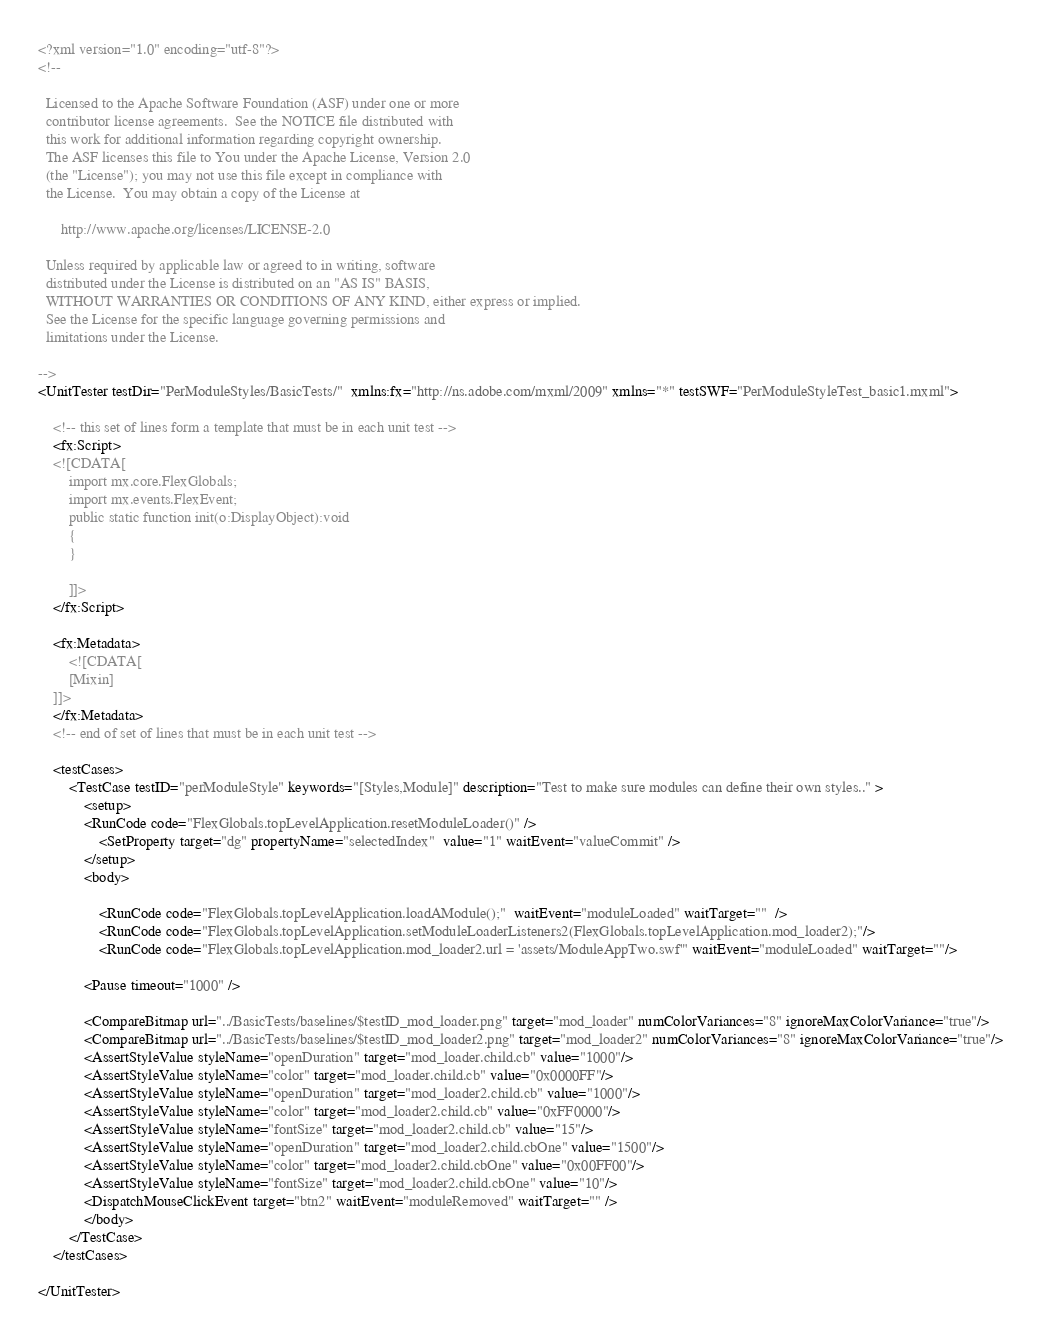Convert code to text. <code><loc_0><loc_0><loc_500><loc_500><_XML_><?xml version="1.0" encoding="utf-8"?>
<!--

  Licensed to the Apache Software Foundation (ASF) under one or more
  contributor license agreements.  See the NOTICE file distributed with
  this work for additional information regarding copyright ownership.
  The ASF licenses this file to You under the Apache License, Version 2.0
  (the "License"); you may not use this file except in compliance with
  the License.  You may obtain a copy of the License at

      http://www.apache.org/licenses/LICENSE-2.0

  Unless required by applicable law or agreed to in writing, software
  distributed under the License is distributed on an "AS IS" BASIS,
  WITHOUT WARRANTIES OR CONDITIONS OF ANY KIND, either express or implied.
  See the License for the specific language governing permissions and
  limitations under the License.

-->
<UnitTester testDir="PerModuleStyles/BasicTests/"  xmlns:fx="http://ns.adobe.com/mxml/2009" xmlns="*" testSWF="PerModuleStyleTest_basic1.mxml">

	<!-- this set of lines form a template that must be in each unit test -->
	<fx:Script>
	<![CDATA[
		import mx.core.FlexGlobals;
		import mx.events.FlexEvent;	
		public static function init(o:DisplayObject):void
		{
		}
		
		]]>
	</fx:Script>

	<fx:Metadata>
		<![CDATA[
		[Mixin]
	]]>
	</fx:Metadata>
	<!-- end of set of lines that must be in each unit test -->

	<testCases>
		<TestCase testID="perModuleStyle" keywords="[Styles,Module]" description="Test to make sure modules can define their own styles.." >
		    <setup>
		   	<RunCode code="FlexGlobals.topLevelApplication.resetModuleLoader()" />
		    	<SetProperty target="dg" propertyName="selectedIndex"  value="1" waitEvent="valueCommit" />
		    </setup>
		    <body>		
		    	
		    	<RunCode code="FlexGlobals.topLevelApplication.loadAModule();"  waitEvent="moduleLoaded" waitTarget=""  />
		    	<RunCode code="FlexGlobals.topLevelApplication.setModuleLoaderListeners2(FlexGlobals.topLevelApplication.mod_loader2);"/>
		    	<RunCode code="FlexGlobals.topLevelApplication.mod_loader2.url = 'assets/ModuleAppTwo.swf'" waitEvent="moduleLoaded" waitTarget=""/>
		    	
			<Pause timeout="1000" />
			
			<CompareBitmap url="../BasicTests/baselines/$testID_mod_loader.png" target="mod_loader" numColorVariances="8" ignoreMaxColorVariance="true"/>
			<CompareBitmap url="../BasicTests/baselines/$testID_mod_loader2.png" target="mod_loader2" numColorVariances="8" ignoreMaxColorVariance="true"/>
			<AssertStyleValue styleName="openDuration" target="mod_loader.child.cb" value="1000"/>
			<AssertStyleValue styleName="color" target="mod_loader.child.cb" value="0x0000FF"/>
			<AssertStyleValue styleName="openDuration" target="mod_loader2.child.cb" value="1000"/>
			<AssertStyleValue styleName="color" target="mod_loader2.child.cb" value="0xFF0000"/>
			<AssertStyleValue styleName="fontSize" target="mod_loader2.child.cb" value="15"/>
			<AssertStyleValue styleName="openDuration" target="mod_loader2.child.cbOne" value="1500"/>
			<AssertStyleValue styleName="color" target="mod_loader2.child.cbOne" value="0x00FF00"/>
			<AssertStyleValue styleName="fontSize" target="mod_loader2.child.cbOne" value="10"/>
			<DispatchMouseClickEvent target="btn2" waitEvent="moduleRemoved" waitTarget="" />
		    </body>
		</TestCase>
	</testCases>

</UnitTester></code> 